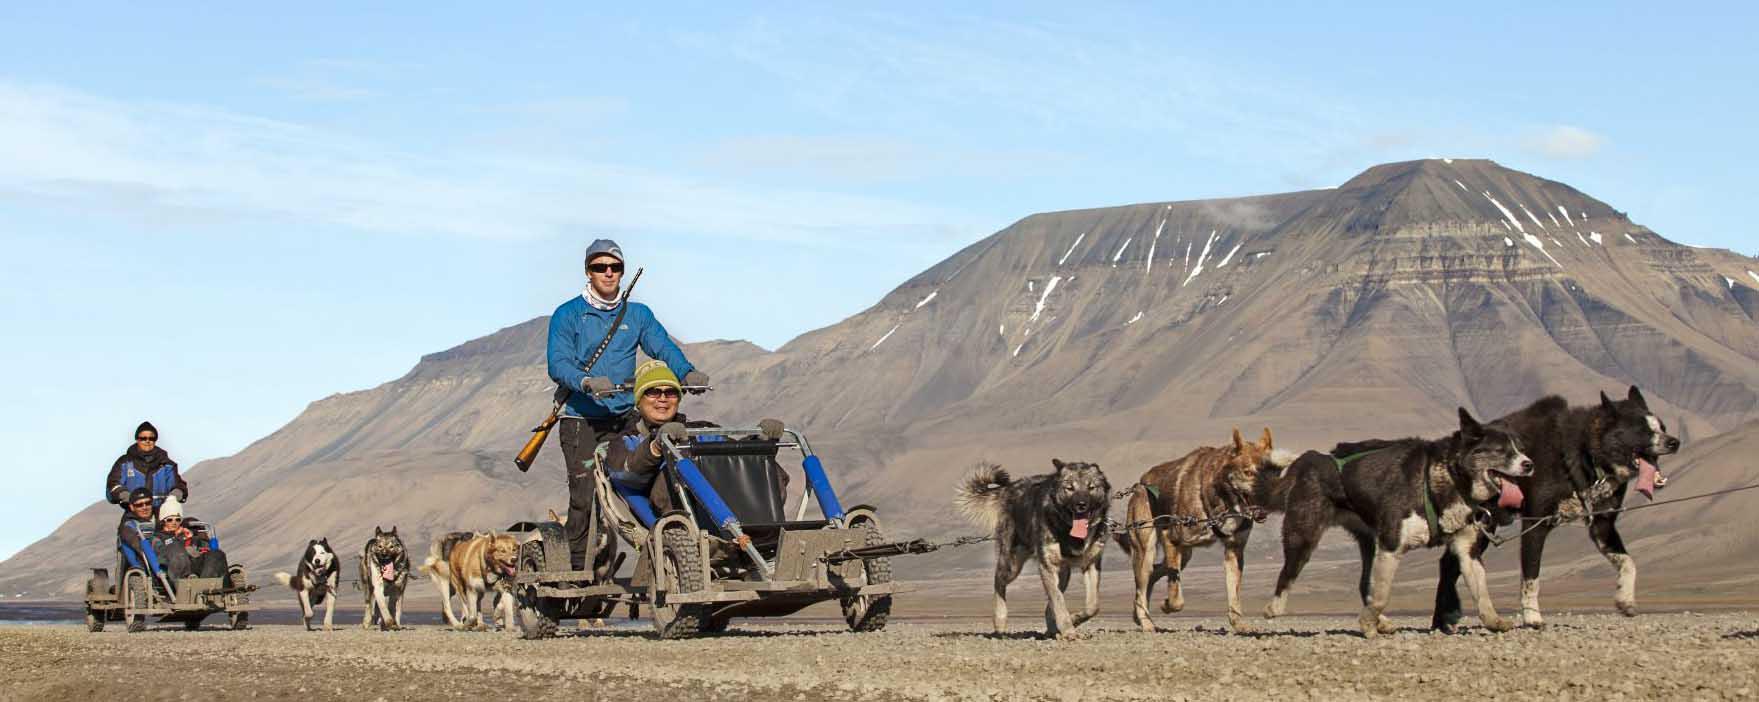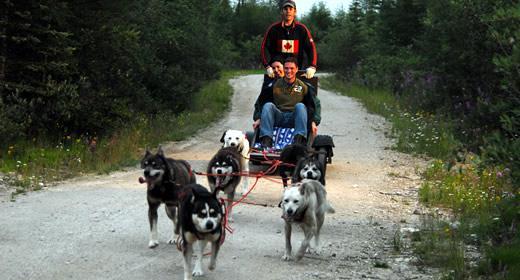The first image is the image on the left, the second image is the image on the right. Examine the images to the left and right. Is the description "Three people are riding a sled in one of the images." accurate? Answer yes or no. Yes. The first image is the image on the left, the second image is the image on the right. For the images displayed, is the sentence "Right image shows a team of sled dogs headed straight toward the camera, and left image includes treeless mountains." factually correct? Answer yes or no. Yes. 